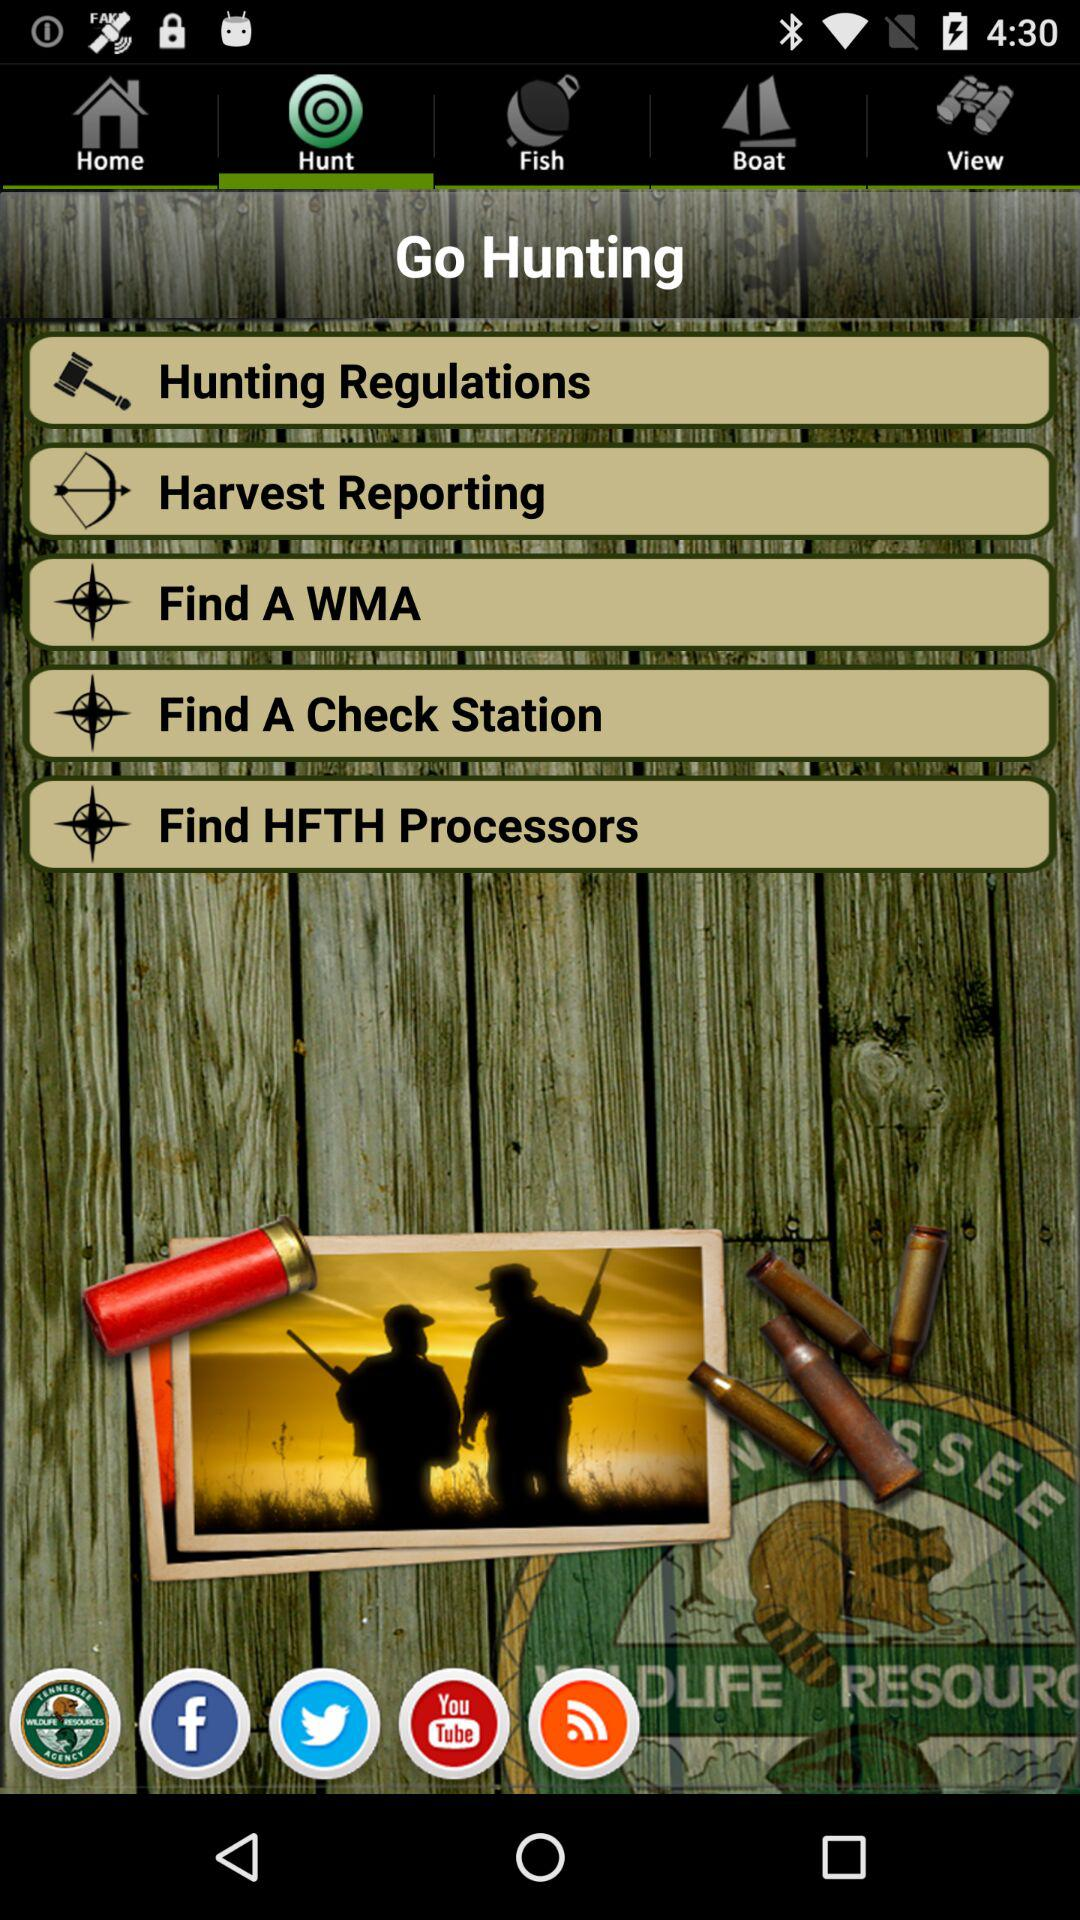What is the name of the application? The name of the application is "Go Hunting". 